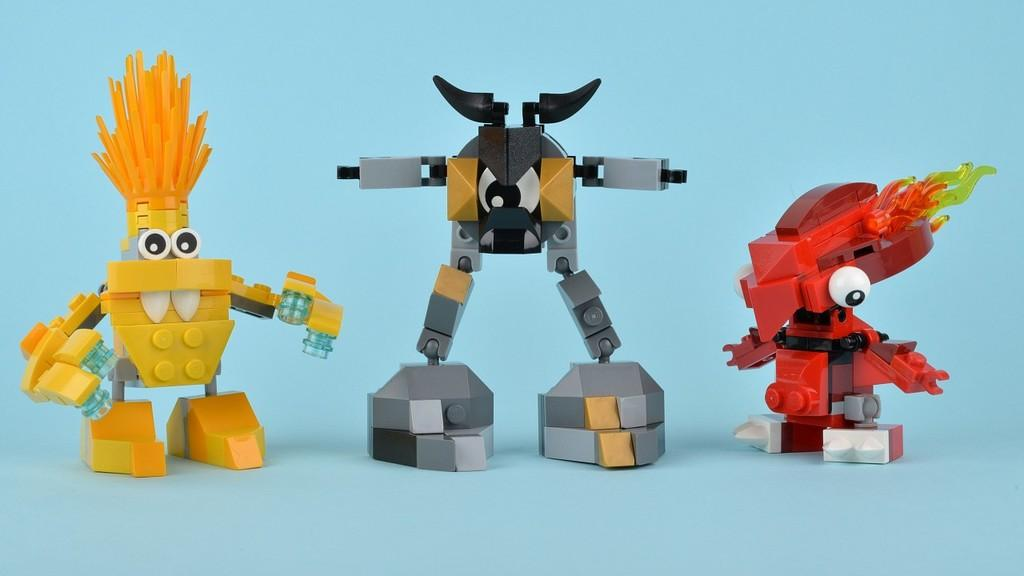What type of objects can be seen in the image? There are toys present in the image. What thoughts does the ladybug have while observing the toys in the image? There is no ladybug present in the image, so it is not possible to determine its thoughts. 